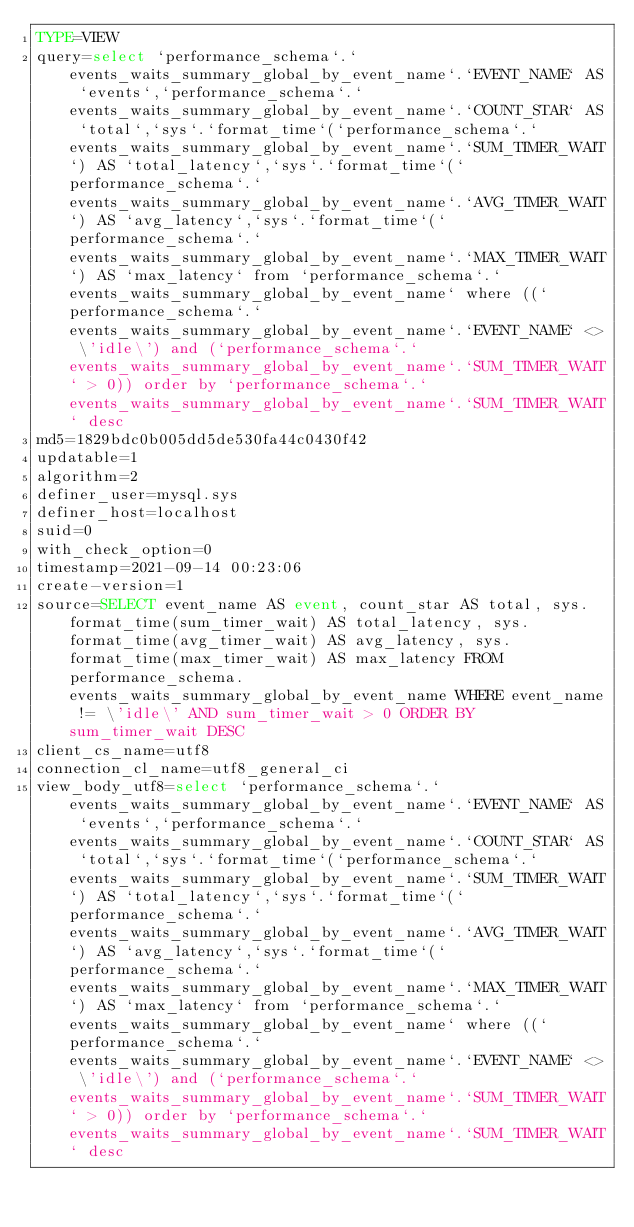Convert code to text. <code><loc_0><loc_0><loc_500><loc_500><_VisualBasic_>TYPE=VIEW
query=select `performance_schema`.`events_waits_summary_global_by_event_name`.`EVENT_NAME` AS `events`,`performance_schema`.`events_waits_summary_global_by_event_name`.`COUNT_STAR` AS `total`,`sys`.`format_time`(`performance_schema`.`events_waits_summary_global_by_event_name`.`SUM_TIMER_WAIT`) AS `total_latency`,`sys`.`format_time`(`performance_schema`.`events_waits_summary_global_by_event_name`.`AVG_TIMER_WAIT`) AS `avg_latency`,`sys`.`format_time`(`performance_schema`.`events_waits_summary_global_by_event_name`.`MAX_TIMER_WAIT`) AS `max_latency` from `performance_schema`.`events_waits_summary_global_by_event_name` where ((`performance_schema`.`events_waits_summary_global_by_event_name`.`EVENT_NAME` <> \'idle\') and (`performance_schema`.`events_waits_summary_global_by_event_name`.`SUM_TIMER_WAIT` > 0)) order by `performance_schema`.`events_waits_summary_global_by_event_name`.`SUM_TIMER_WAIT` desc
md5=1829bdc0b005dd5de530fa44c0430f42
updatable=1
algorithm=2
definer_user=mysql.sys
definer_host=localhost
suid=0
with_check_option=0
timestamp=2021-09-14 00:23:06
create-version=1
source=SELECT event_name AS event, count_star AS total, sys.format_time(sum_timer_wait) AS total_latency, sys.format_time(avg_timer_wait) AS avg_latency, sys.format_time(max_timer_wait) AS max_latency FROM performance_schema.events_waits_summary_global_by_event_name WHERE event_name != \'idle\' AND sum_timer_wait > 0 ORDER BY sum_timer_wait DESC
client_cs_name=utf8
connection_cl_name=utf8_general_ci
view_body_utf8=select `performance_schema`.`events_waits_summary_global_by_event_name`.`EVENT_NAME` AS `events`,`performance_schema`.`events_waits_summary_global_by_event_name`.`COUNT_STAR` AS `total`,`sys`.`format_time`(`performance_schema`.`events_waits_summary_global_by_event_name`.`SUM_TIMER_WAIT`) AS `total_latency`,`sys`.`format_time`(`performance_schema`.`events_waits_summary_global_by_event_name`.`AVG_TIMER_WAIT`) AS `avg_latency`,`sys`.`format_time`(`performance_schema`.`events_waits_summary_global_by_event_name`.`MAX_TIMER_WAIT`) AS `max_latency` from `performance_schema`.`events_waits_summary_global_by_event_name` where ((`performance_schema`.`events_waits_summary_global_by_event_name`.`EVENT_NAME` <> \'idle\') and (`performance_schema`.`events_waits_summary_global_by_event_name`.`SUM_TIMER_WAIT` > 0)) order by `performance_schema`.`events_waits_summary_global_by_event_name`.`SUM_TIMER_WAIT` desc
</code> 